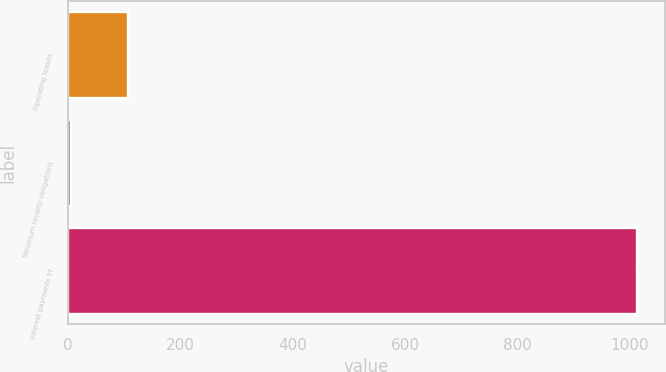Convert chart. <chart><loc_0><loc_0><loc_500><loc_500><bar_chart><fcel>Operating leases<fcel>Minimum royalty obligations<fcel>Interest payments ††<nl><fcel>106.7<fcel>6<fcel>1013<nl></chart> 